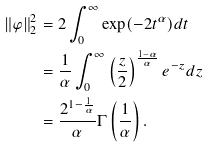Convert formula to latex. <formula><loc_0><loc_0><loc_500><loc_500>\| \varphi \| _ { 2 } ^ { 2 } & = 2 \int _ { 0 } ^ { \infty } \exp ( - 2 t ^ { \alpha } ) d t \\ & = \frac { 1 } { \alpha } \int _ { 0 } ^ { \infty } \left ( \frac { z } { 2 } \right ) ^ { \frac { 1 - \alpha } { \alpha } } e ^ { - z } d z \\ & = \frac { 2 ^ { 1 - \frac { 1 } { \alpha } } } { \alpha } \Gamma \left ( \frac { 1 } { \alpha } \right ) .</formula> 